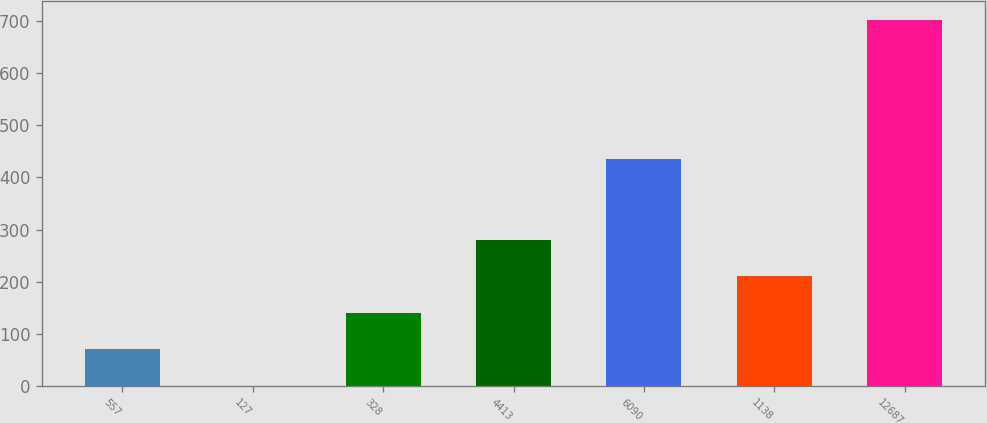<chart> <loc_0><loc_0><loc_500><loc_500><bar_chart><fcel>557<fcel>127<fcel>328<fcel>4413<fcel>6090<fcel>1138<fcel>12687<nl><fcel>70.31<fcel>0.1<fcel>140.52<fcel>280.94<fcel>435.8<fcel>210.73<fcel>702.2<nl></chart> 